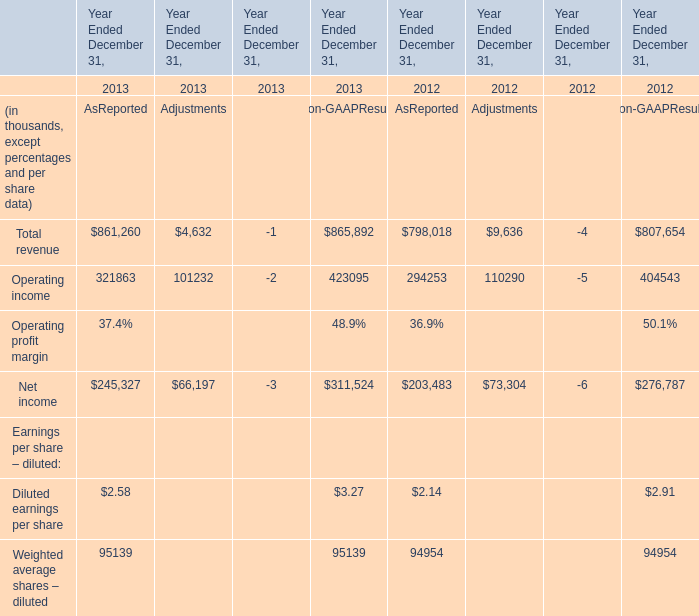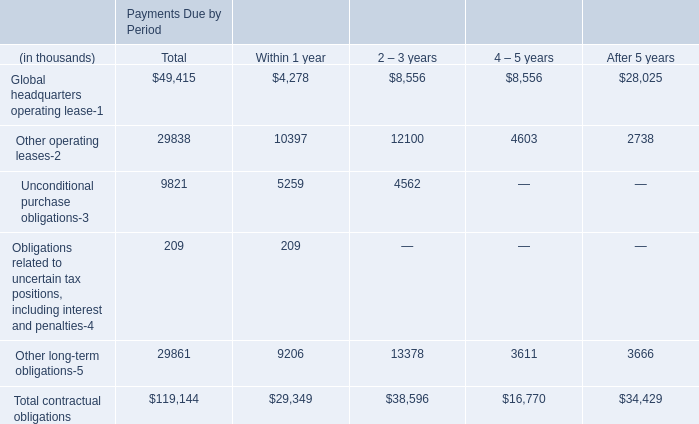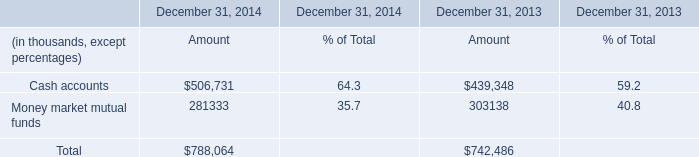What will Total revenue as reported be like in 2014 if it continues to grow at the same rate as it did in 2013? (in thousand) 
Computations: (861260 + ((861260 * (861260 - 798018)) / 798018))
Answer: 929513.85508. 